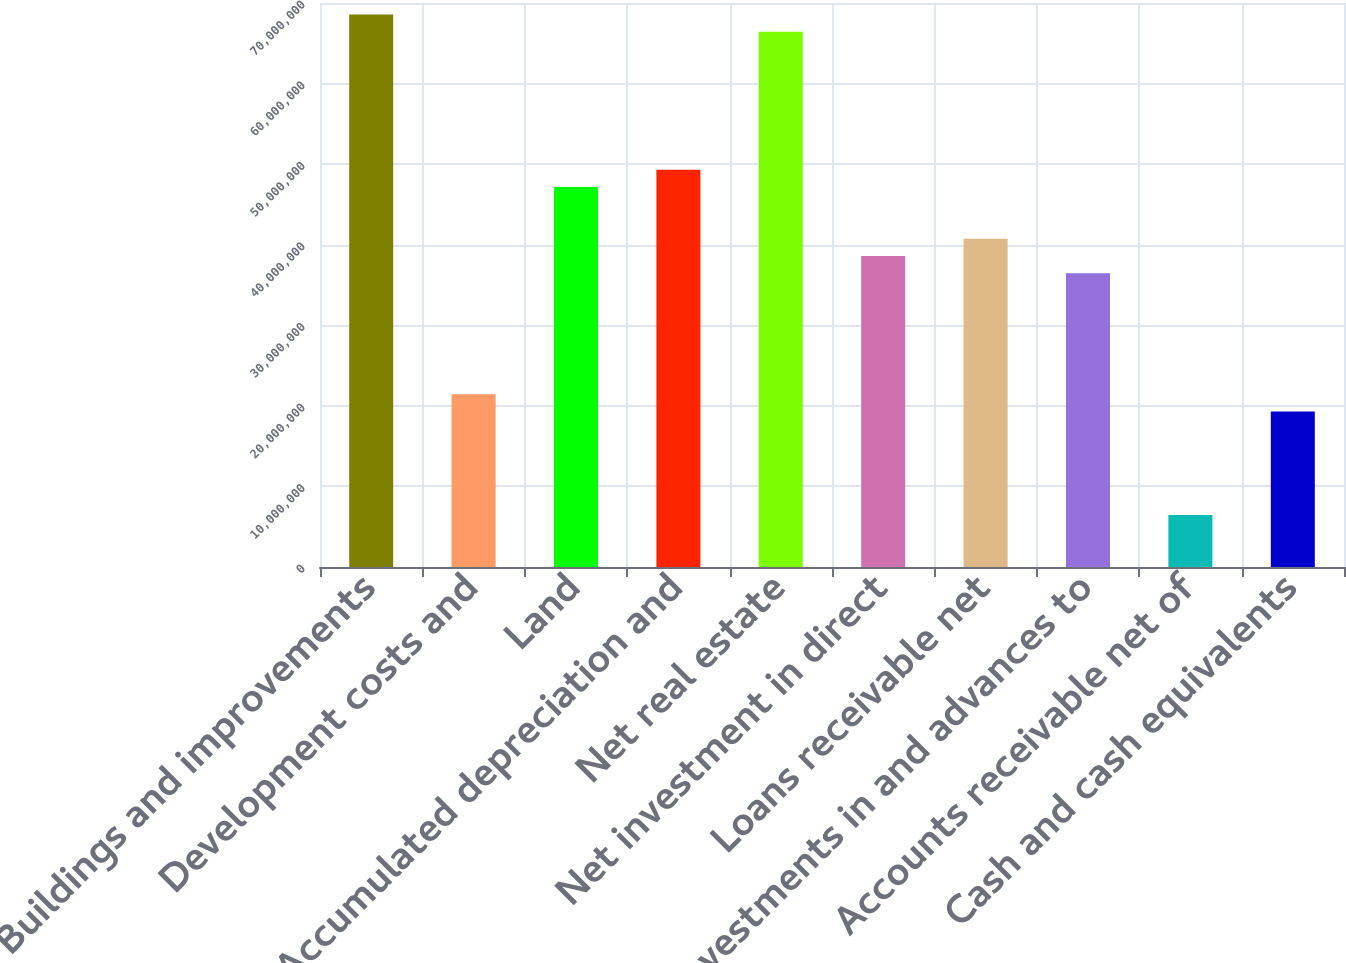Convert chart. <chart><loc_0><loc_0><loc_500><loc_500><bar_chart><fcel>Buildings and improvements<fcel>Development costs and<fcel>Land<fcel>Accumulated depreciation and<fcel>Net real estate<fcel>Net investment in direct<fcel>Loans receivable net<fcel>Investments in and advances to<fcel>Accounts receivable net of<fcel>Cash and cash equivalents<nl><fcel>6.85839e+07<fcel>2.14498e+07<fcel>4.71593e+07<fcel>4.93018e+07<fcel>6.64415e+07<fcel>3.85895e+07<fcel>4.0732e+07<fcel>3.64471e+07<fcel>6.45264e+06<fcel>1.93074e+07<nl></chart> 